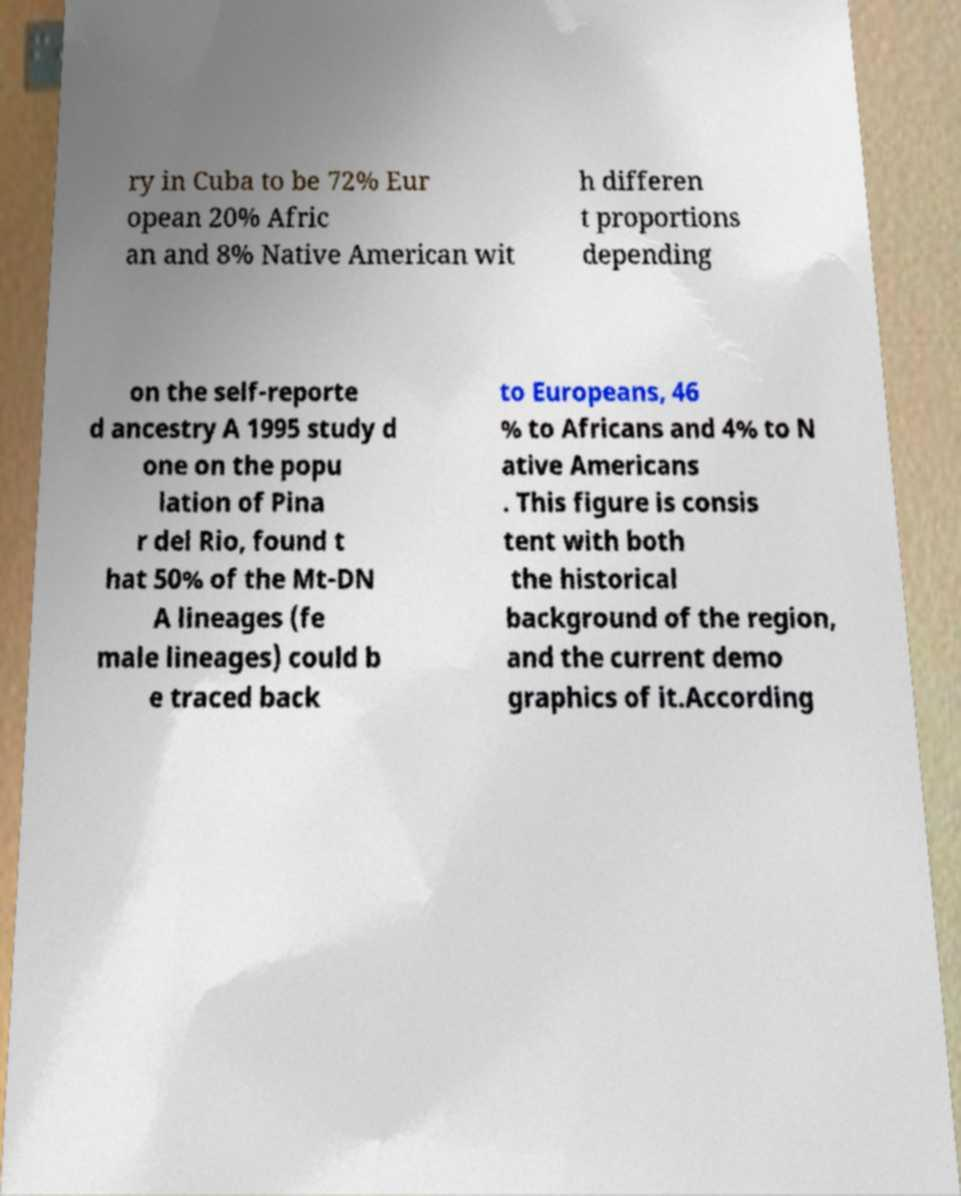Please read and relay the text visible in this image. What does it say? ry in Cuba to be 72% Eur opean 20% Afric an and 8% Native American wit h differen t proportions depending on the self-reporte d ancestry A 1995 study d one on the popu lation of Pina r del Rio, found t hat 50% of the Mt-DN A lineages (fe male lineages) could b e traced back to Europeans, 46 % to Africans and 4% to N ative Americans . This figure is consis tent with both the historical background of the region, and the current demo graphics of it.According 